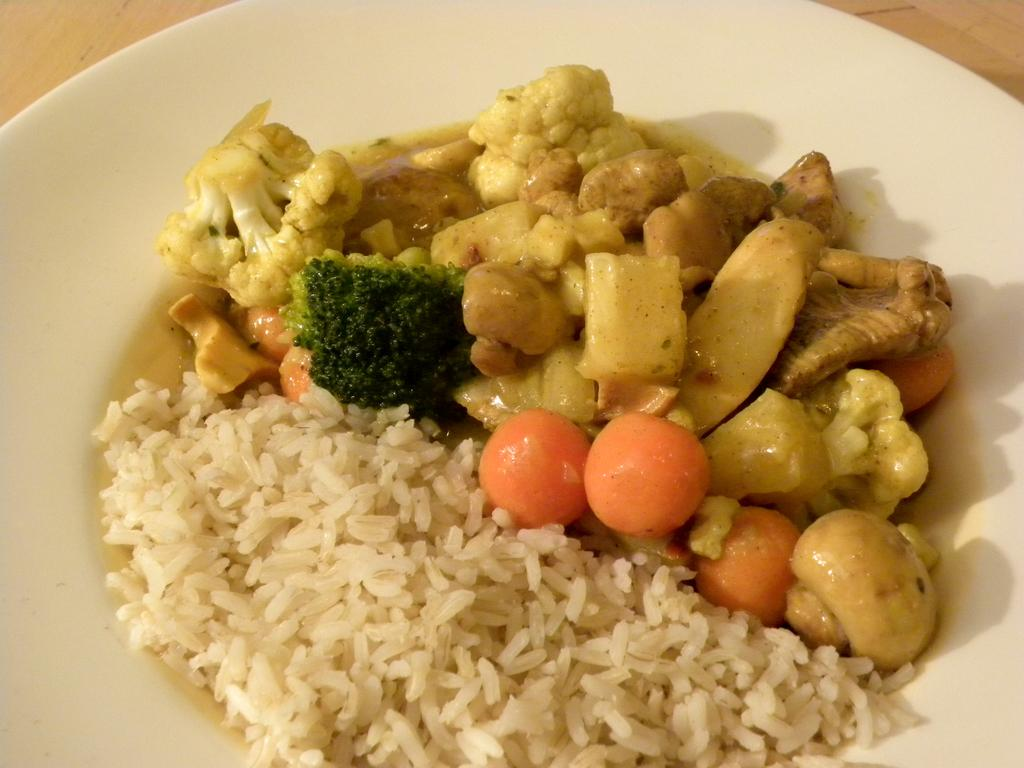What type of food can be seen in the image? The image contains food with white, orange, green, and brown colors. What is the color of the plate on which the food is served? The plate is white. How many visitors can be seen on the island in the image? There is no island or visitors present in the image; it features food on a white plate. 